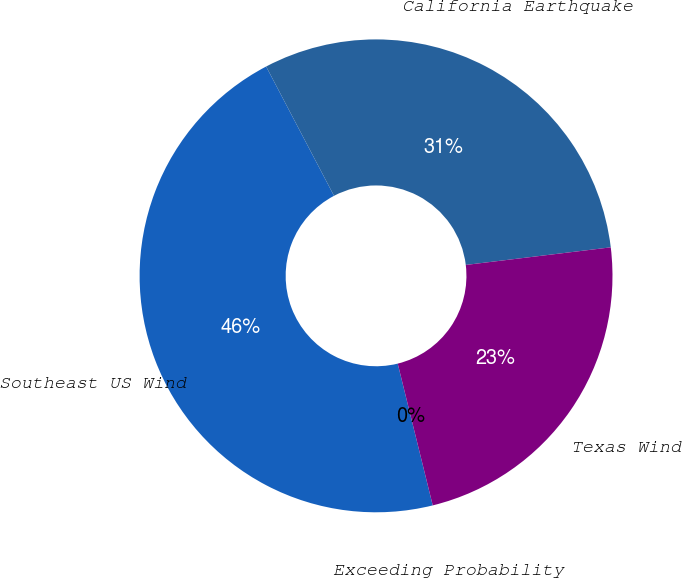<chart> <loc_0><loc_0><loc_500><loc_500><pie_chart><fcel>Exceeding Probability<fcel>Southeast US Wind<fcel>California Earthquake<fcel>Texas Wind<nl><fcel>0.0%<fcel>46.16%<fcel>30.77%<fcel>23.07%<nl></chart> 